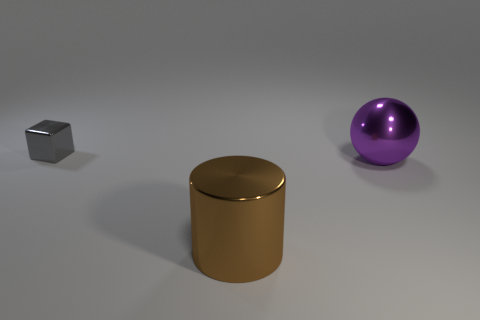There is a gray block that is made of the same material as the brown thing; what is its size?
Keep it short and to the point. Small. What color is the shiny object that is both in front of the tiny gray cube and on the left side of the big purple metallic object?
Your answer should be compact. Brown. What number of metal balls are the same size as the cylinder?
Provide a short and direct response. 1. There is a metallic thing that is behind the brown metal thing and on the right side of the tiny metal cube; how big is it?
Your response must be concise. Large. How many big cylinders are to the left of the shiny object left of the large metallic thing in front of the purple shiny object?
Give a very brief answer. 0. Are there any big things that have the same color as the big metallic sphere?
Provide a short and direct response. No. What color is the thing that is the same size as the cylinder?
Provide a succinct answer. Purple. There is a thing that is in front of the metal object to the right of the big thing to the left of the big sphere; what is its shape?
Provide a succinct answer. Cylinder. There is a shiny object in front of the large purple metal sphere; how many purple metallic spheres are in front of it?
Make the answer very short. 0. There is a thing that is in front of the purple ball; does it have the same shape as the gray metal thing that is behind the purple sphere?
Your answer should be very brief. No. 